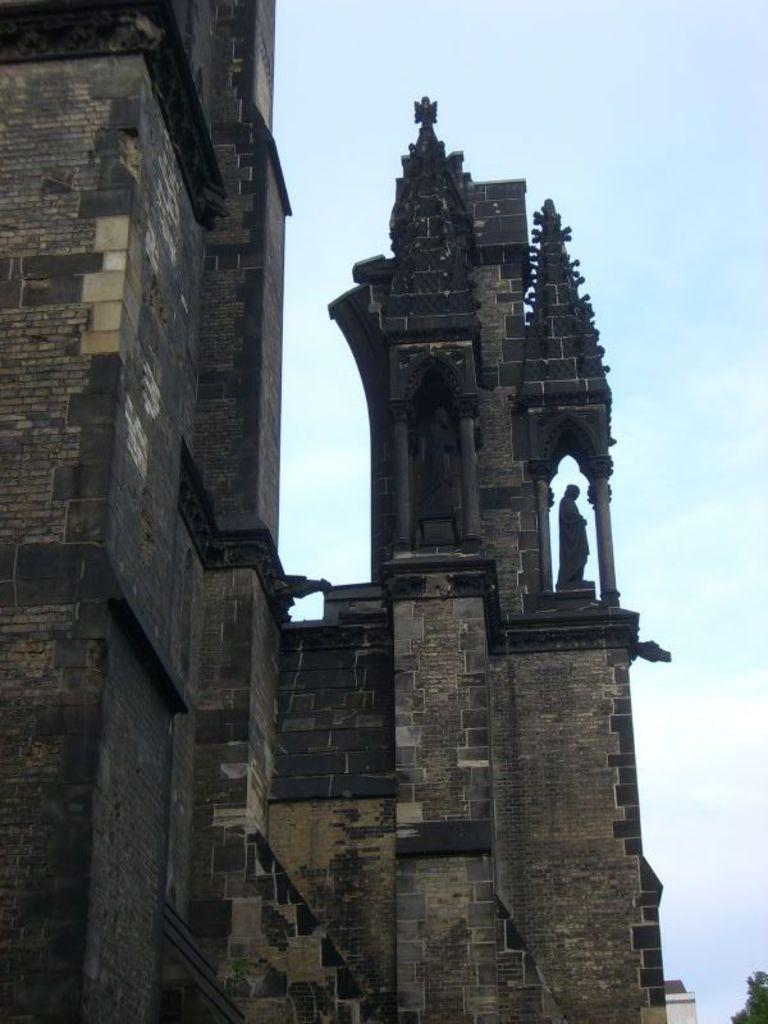What type of structure is present in the image? There is a building in the image. What other object can be seen in the image? There is a statue in the image. What can be seen in the background of the image? There is a tree in the background of the image. What is the color of the tree? The tree is green. What is visible above the tree and the statue? The sky is visible in the image. How would you describe the color of the sky? The sky has both white and blue colors. What type of fear is depicted in the statue's expression in the image? There is no fear depicted in the statue's expression in the image, as the statue is an inanimate object and does not have emotions or expressions. 